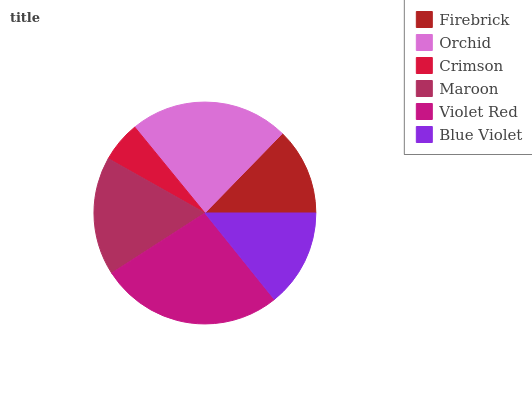Is Crimson the minimum?
Answer yes or no. Yes. Is Violet Red the maximum?
Answer yes or no. Yes. Is Orchid the minimum?
Answer yes or no. No. Is Orchid the maximum?
Answer yes or no. No. Is Orchid greater than Firebrick?
Answer yes or no. Yes. Is Firebrick less than Orchid?
Answer yes or no. Yes. Is Firebrick greater than Orchid?
Answer yes or no. No. Is Orchid less than Firebrick?
Answer yes or no. No. Is Maroon the high median?
Answer yes or no. Yes. Is Blue Violet the low median?
Answer yes or no. Yes. Is Violet Red the high median?
Answer yes or no. No. Is Crimson the low median?
Answer yes or no. No. 